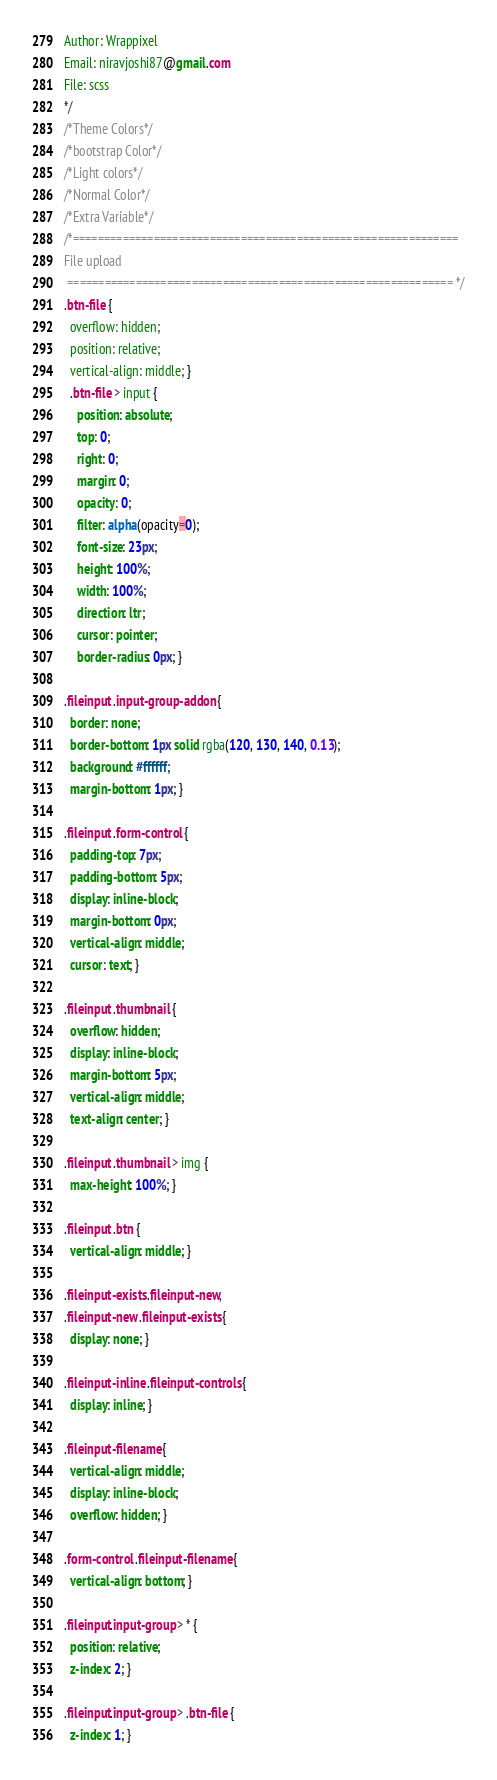Convert code to text. <code><loc_0><loc_0><loc_500><loc_500><_CSS_>Author: Wrappixel
Email: niravjoshi87@gmail.com
File: scss
*/
/*Theme Colors*/
/*bootstrap Color*/
/*Light colors*/
/*Normal Color*/
/*Extra Variable*/
/*============================================================== 
File upload
 ============================================================== */
.btn-file {
  overflow: hidden;
  position: relative;
  vertical-align: middle; }
  .btn-file > input {
    position: absolute;
    top: 0;
    right: 0;
    margin: 0;
    opacity: 0;
    filter: alpha(opacity=0);
    font-size: 23px;
    height: 100%;
    width: 100%;
    direction: ltr;
    cursor: pointer;
    border-radius: 0px; }

.fileinput .input-group-addon {
  border: none;
  border-bottom: 1px solid rgba(120, 130, 140, 0.13);
  background: #ffffff;
  margin-bottom: 1px; }

.fileinput .form-control {
  padding-top: 7px;
  padding-bottom: 5px;
  display: inline-block;
  margin-bottom: 0px;
  vertical-align: middle;
  cursor: text; }

.fileinput .thumbnail {
  overflow: hidden;
  display: inline-block;
  margin-bottom: 5px;
  vertical-align: middle;
  text-align: center; }

.fileinput .thumbnail > img {
  max-height: 100%; }

.fileinput .btn {
  vertical-align: middle; }

.fileinput-exists .fileinput-new,
.fileinput-new .fileinput-exists {
  display: none; }

.fileinput-inline .fileinput-controls {
  display: inline; }

.fileinput-filename {
  vertical-align: middle;
  display: inline-block;
  overflow: hidden; }

.form-control .fileinput-filename {
  vertical-align: bottom; }

.fileinput.input-group > * {
  position: relative;
  z-index: 2; }

.fileinput.input-group > .btn-file {
  z-index: 1; }
</code> 